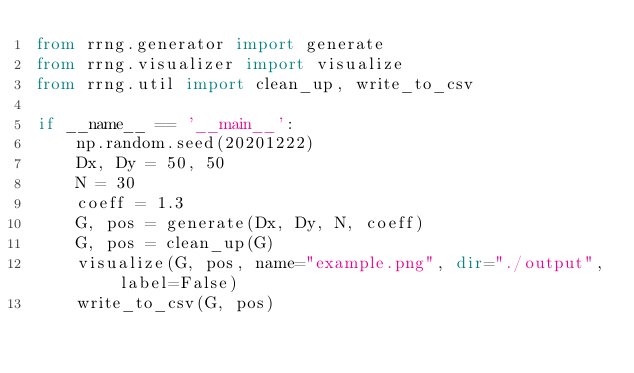Convert code to text. <code><loc_0><loc_0><loc_500><loc_500><_Python_>from rrng.generator import generate
from rrng.visualizer import visualize
from rrng.util import clean_up, write_to_csv

if __name__ == '__main__':
    np.random.seed(20201222)
    Dx, Dy = 50, 50
    N = 30
    coeff = 1.3
    G, pos = generate(Dx, Dy, N, coeff)
    G, pos = clean_up(G)
    visualize(G, pos, name="example.png", dir="./output", label=False)
    write_to_csv(G, pos)
</code> 